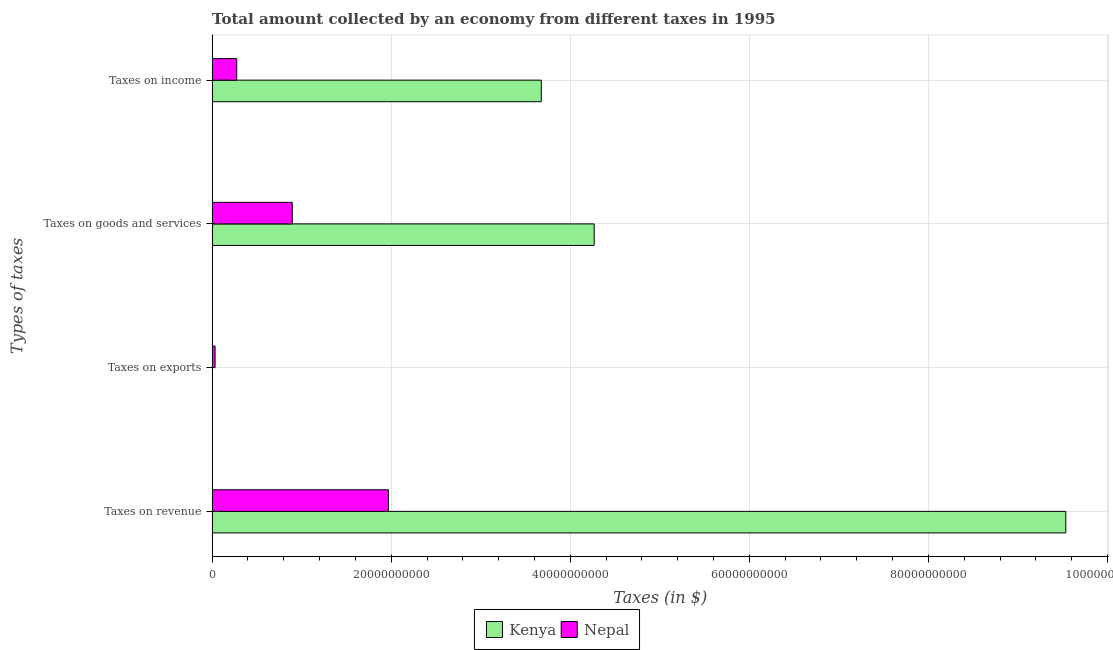Are the number of bars per tick equal to the number of legend labels?
Your response must be concise. Yes. Are the number of bars on each tick of the Y-axis equal?
Your answer should be very brief. Yes. What is the label of the 1st group of bars from the top?
Keep it short and to the point. Taxes on income. What is the amount collected as tax on revenue in Nepal?
Offer a very short reply. 1.97e+1. Across all countries, what is the maximum amount collected as tax on goods?
Provide a succinct answer. 4.27e+1. Across all countries, what is the minimum amount collected as tax on goods?
Your response must be concise. 8.95e+09. In which country was the amount collected as tax on exports maximum?
Your answer should be very brief. Nepal. In which country was the amount collected as tax on income minimum?
Ensure brevity in your answer.  Nepal. What is the total amount collected as tax on goods in the graph?
Give a very brief answer. 5.16e+1. What is the difference between the amount collected as tax on goods in Nepal and that in Kenya?
Offer a very short reply. -3.37e+1. What is the difference between the amount collected as tax on income in Nepal and the amount collected as tax on exports in Kenya?
Your answer should be very brief. 2.75e+09. What is the average amount collected as tax on revenue per country?
Give a very brief answer. 5.75e+1. What is the difference between the amount collected as tax on goods and amount collected as tax on exports in Kenya?
Keep it short and to the point. 4.27e+1. In how many countries, is the amount collected as tax on exports greater than 88000000000 $?
Provide a short and direct response. 0. What is the ratio of the amount collected as tax on income in Kenya to that in Nepal?
Your answer should be very brief. 13.36. Is the difference between the amount collected as tax on income in Kenya and Nepal greater than the difference between the amount collected as tax on goods in Kenya and Nepal?
Offer a very short reply. Yes. What is the difference between the highest and the second highest amount collected as tax on goods?
Ensure brevity in your answer.  3.37e+1. What is the difference between the highest and the lowest amount collected as tax on exports?
Your answer should be compact. 3.29e+08. In how many countries, is the amount collected as tax on revenue greater than the average amount collected as tax on revenue taken over all countries?
Your response must be concise. 1. Is it the case that in every country, the sum of the amount collected as tax on revenue and amount collected as tax on goods is greater than the sum of amount collected as tax on income and amount collected as tax on exports?
Your answer should be compact. No. What does the 1st bar from the top in Taxes on goods and services represents?
Keep it short and to the point. Nepal. What does the 1st bar from the bottom in Taxes on exports represents?
Your answer should be compact. Kenya. Is it the case that in every country, the sum of the amount collected as tax on revenue and amount collected as tax on exports is greater than the amount collected as tax on goods?
Your answer should be very brief. Yes. How many countries are there in the graph?
Offer a terse response. 2. What is the difference between two consecutive major ticks on the X-axis?
Keep it short and to the point. 2.00e+1. Does the graph contain any zero values?
Provide a short and direct response. No. Does the graph contain grids?
Your answer should be compact. Yes. How many legend labels are there?
Your answer should be compact. 2. How are the legend labels stacked?
Offer a terse response. Horizontal. What is the title of the graph?
Keep it short and to the point. Total amount collected by an economy from different taxes in 1995. What is the label or title of the X-axis?
Offer a very short reply. Taxes (in $). What is the label or title of the Y-axis?
Make the answer very short. Types of taxes. What is the Taxes (in $) in Kenya in Taxes on revenue?
Offer a very short reply. 9.54e+1. What is the Taxes (in $) of Nepal in Taxes on revenue?
Offer a very short reply. 1.97e+1. What is the Taxes (in $) in Nepal in Taxes on exports?
Give a very brief answer. 3.32e+08. What is the Taxes (in $) of Kenya in Taxes on goods and services?
Your response must be concise. 4.27e+1. What is the Taxes (in $) of Nepal in Taxes on goods and services?
Keep it short and to the point. 8.95e+09. What is the Taxes (in $) of Kenya in Taxes on income?
Your answer should be compact. 3.68e+1. What is the Taxes (in $) in Nepal in Taxes on income?
Provide a short and direct response. 2.75e+09. Across all Types of taxes, what is the maximum Taxes (in $) in Kenya?
Your answer should be very brief. 9.54e+1. Across all Types of taxes, what is the maximum Taxes (in $) of Nepal?
Provide a short and direct response. 1.97e+1. Across all Types of taxes, what is the minimum Taxes (in $) in Nepal?
Your answer should be compact. 3.32e+08. What is the total Taxes (in $) in Kenya in the graph?
Provide a short and direct response. 1.75e+11. What is the total Taxes (in $) of Nepal in the graph?
Provide a short and direct response. 3.17e+1. What is the difference between the Taxes (in $) of Kenya in Taxes on revenue and that in Taxes on exports?
Provide a succinct answer. 9.53e+1. What is the difference between the Taxes (in $) in Nepal in Taxes on revenue and that in Taxes on exports?
Provide a succinct answer. 1.94e+1. What is the difference between the Taxes (in $) in Kenya in Taxes on revenue and that in Taxes on goods and services?
Ensure brevity in your answer.  5.27e+1. What is the difference between the Taxes (in $) of Nepal in Taxes on revenue and that in Taxes on goods and services?
Offer a terse response. 1.07e+1. What is the difference between the Taxes (in $) of Kenya in Taxes on revenue and that in Taxes on income?
Ensure brevity in your answer.  5.86e+1. What is the difference between the Taxes (in $) of Nepal in Taxes on revenue and that in Taxes on income?
Offer a terse response. 1.69e+1. What is the difference between the Taxes (in $) of Kenya in Taxes on exports and that in Taxes on goods and services?
Give a very brief answer. -4.27e+1. What is the difference between the Taxes (in $) of Nepal in Taxes on exports and that in Taxes on goods and services?
Keep it short and to the point. -8.62e+09. What is the difference between the Taxes (in $) of Kenya in Taxes on exports and that in Taxes on income?
Give a very brief answer. -3.68e+1. What is the difference between the Taxes (in $) of Nepal in Taxes on exports and that in Taxes on income?
Your answer should be very brief. -2.42e+09. What is the difference between the Taxes (in $) in Kenya in Taxes on goods and services and that in Taxes on income?
Provide a short and direct response. 5.91e+09. What is the difference between the Taxes (in $) in Nepal in Taxes on goods and services and that in Taxes on income?
Offer a terse response. 6.20e+09. What is the difference between the Taxes (in $) of Kenya in Taxes on revenue and the Taxes (in $) of Nepal in Taxes on exports?
Ensure brevity in your answer.  9.50e+1. What is the difference between the Taxes (in $) of Kenya in Taxes on revenue and the Taxes (in $) of Nepal in Taxes on goods and services?
Provide a succinct answer. 8.64e+1. What is the difference between the Taxes (in $) in Kenya in Taxes on revenue and the Taxes (in $) in Nepal in Taxes on income?
Provide a succinct answer. 9.26e+1. What is the difference between the Taxes (in $) of Kenya in Taxes on exports and the Taxes (in $) of Nepal in Taxes on goods and services?
Your response must be concise. -8.95e+09. What is the difference between the Taxes (in $) of Kenya in Taxes on exports and the Taxes (in $) of Nepal in Taxes on income?
Keep it short and to the point. -2.75e+09. What is the difference between the Taxes (in $) in Kenya in Taxes on goods and services and the Taxes (in $) in Nepal in Taxes on income?
Offer a terse response. 3.99e+1. What is the average Taxes (in $) of Kenya per Types of taxes?
Make the answer very short. 4.37e+1. What is the average Taxes (in $) of Nepal per Types of taxes?
Your response must be concise. 7.93e+09. What is the difference between the Taxes (in $) in Kenya and Taxes (in $) in Nepal in Taxes on revenue?
Offer a very short reply. 7.57e+1. What is the difference between the Taxes (in $) in Kenya and Taxes (in $) in Nepal in Taxes on exports?
Make the answer very short. -3.29e+08. What is the difference between the Taxes (in $) in Kenya and Taxes (in $) in Nepal in Taxes on goods and services?
Keep it short and to the point. 3.37e+1. What is the difference between the Taxes (in $) of Kenya and Taxes (in $) of Nepal in Taxes on income?
Provide a short and direct response. 3.40e+1. What is the ratio of the Taxes (in $) in Kenya in Taxes on revenue to that in Taxes on exports?
Give a very brief answer. 3.18e+04. What is the ratio of the Taxes (in $) in Nepal in Taxes on revenue to that in Taxes on exports?
Ensure brevity in your answer.  59.32. What is the ratio of the Taxes (in $) of Kenya in Taxes on revenue to that in Taxes on goods and services?
Offer a very short reply. 2.23. What is the ratio of the Taxes (in $) in Nepal in Taxes on revenue to that in Taxes on goods and services?
Keep it short and to the point. 2.2. What is the ratio of the Taxes (in $) in Kenya in Taxes on revenue to that in Taxes on income?
Offer a very short reply. 2.59. What is the ratio of the Taxes (in $) of Nepal in Taxes on revenue to that in Taxes on income?
Offer a very short reply. 7.16. What is the ratio of the Taxes (in $) of Nepal in Taxes on exports to that in Taxes on goods and services?
Keep it short and to the point. 0.04. What is the ratio of the Taxes (in $) in Nepal in Taxes on exports to that in Taxes on income?
Your answer should be very brief. 0.12. What is the ratio of the Taxes (in $) in Kenya in Taxes on goods and services to that in Taxes on income?
Ensure brevity in your answer.  1.16. What is the ratio of the Taxes (in $) of Nepal in Taxes on goods and services to that in Taxes on income?
Offer a terse response. 3.25. What is the difference between the highest and the second highest Taxes (in $) in Kenya?
Make the answer very short. 5.27e+1. What is the difference between the highest and the second highest Taxes (in $) in Nepal?
Your answer should be compact. 1.07e+1. What is the difference between the highest and the lowest Taxes (in $) in Kenya?
Your response must be concise. 9.53e+1. What is the difference between the highest and the lowest Taxes (in $) in Nepal?
Keep it short and to the point. 1.94e+1. 